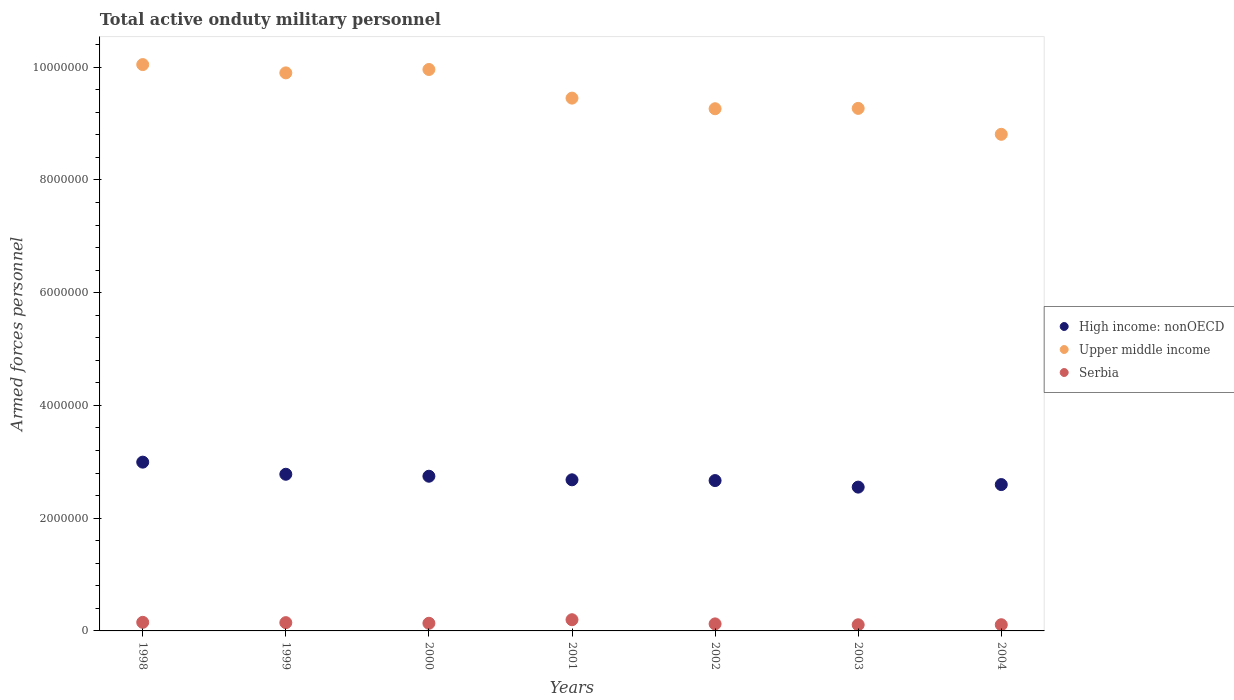How many different coloured dotlines are there?
Offer a very short reply. 3. What is the number of armed forces personnel in Upper middle income in 2002?
Your answer should be compact. 9.26e+06. Across all years, what is the maximum number of armed forces personnel in High income: nonOECD?
Keep it short and to the point. 2.99e+06. Across all years, what is the minimum number of armed forces personnel in Serbia?
Provide a short and direct response. 1.09e+05. In which year was the number of armed forces personnel in High income: nonOECD minimum?
Provide a short and direct response. 2003. What is the total number of armed forces personnel in High income: nonOECD in the graph?
Make the answer very short. 1.90e+07. What is the difference between the number of armed forces personnel in Upper middle income in 1998 and that in 2004?
Keep it short and to the point. 1.24e+06. What is the difference between the number of armed forces personnel in Upper middle income in 2001 and the number of armed forces personnel in High income: nonOECD in 2000?
Ensure brevity in your answer.  6.71e+06. What is the average number of armed forces personnel in Upper middle income per year?
Provide a succinct answer. 9.53e+06. In the year 2002, what is the difference between the number of armed forces personnel in Serbia and number of armed forces personnel in Upper middle income?
Offer a terse response. -9.14e+06. In how many years, is the number of armed forces personnel in Serbia greater than 4800000?
Your response must be concise. 0. What is the ratio of the number of armed forces personnel in High income: nonOECD in 1999 to that in 2001?
Provide a succinct answer. 1.04. What is the difference between the highest and the second highest number of armed forces personnel in High income: nonOECD?
Ensure brevity in your answer.  2.15e+05. What is the difference between the highest and the lowest number of armed forces personnel in Upper middle income?
Ensure brevity in your answer.  1.24e+06. Is the sum of the number of armed forces personnel in Upper middle income in 2000 and 2003 greater than the maximum number of armed forces personnel in High income: nonOECD across all years?
Offer a terse response. Yes. Does the number of armed forces personnel in High income: nonOECD monotonically increase over the years?
Keep it short and to the point. No. How many years are there in the graph?
Make the answer very short. 7. Are the values on the major ticks of Y-axis written in scientific E-notation?
Your answer should be compact. No. Does the graph contain any zero values?
Your response must be concise. No. How are the legend labels stacked?
Offer a very short reply. Vertical. What is the title of the graph?
Make the answer very short. Total active onduty military personnel. Does "Namibia" appear as one of the legend labels in the graph?
Provide a short and direct response. No. What is the label or title of the X-axis?
Your answer should be very brief. Years. What is the label or title of the Y-axis?
Keep it short and to the point. Armed forces personnel. What is the Armed forces personnel of High income: nonOECD in 1998?
Offer a terse response. 2.99e+06. What is the Armed forces personnel in Upper middle income in 1998?
Make the answer very short. 1.00e+07. What is the Armed forces personnel of Serbia in 1998?
Provide a succinct answer. 1.52e+05. What is the Armed forces personnel in High income: nonOECD in 1999?
Your answer should be compact. 2.78e+06. What is the Armed forces personnel in Upper middle income in 1999?
Provide a short and direct response. 9.90e+06. What is the Armed forces personnel of Serbia in 1999?
Your answer should be compact. 1.47e+05. What is the Armed forces personnel of High income: nonOECD in 2000?
Offer a very short reply. 2.74e+06. What is the Armed forces personnel in Upper middle income in 2000?
Your answer should be compact. 9.96e+06. What is the Armed forces personnel of Serbia in 2000?
Your answer should be compact. 1.36e+05. What is the Armed forces personnel of High income: nonOECD in 2001?
Your answer should be compact. 2.68e+06. What is the Armed forces personnel in Upper middle income in 2001?
Make the answer very short. 9.45e+06. What is the Armed forces personnel of Serbia in 2001?
Keep it short and to the point. 1.98e+05. What is the Armed forces personnel of High income: nonOECD in 2002?
Make the answer very short. 2.67e+06. What is the Armed forces personnel in Upper middle income in 2002?
Give a very brief answer. 9.26e+06. What is the Armed forces personnel in Serbia in 2002?
Offer a terse response. 1.24e+05. What is the Armed forces personnel of High income: nonOECD in 2003?
Your answer should be very brief. 2.55e+06. What is the Armed forces personnel in Upper middle income in 2003?
Ensure brevity in your answer.  9.27e+06. What is the Armed forces personnel of Serbia in 2003?
Offer a terse response. 1.09e+05. What is the Armed forces personnel of High income: nonOECD in 2004?
Provide a short and direct response. 2.60e+06. What is the Armed forces personnel of Upper middle income in 2004?
Make the answer very short. 8.81e+06. What is the Armed forces personnel of Serbia in 2004?
Your response must be concise. 1.10e+05. Across all years, what is the maximum Armed forces personnel in High income: nonOECD?
Keep it short and to the point. 2.99e+06. Across all years, what is the maximum Armed forces personnel in Upper middle income?
Provide a short and direct response. 1.00e+07. Across all years, what is the maximum Armed forces personnel of Serbia?
Offer a very short reply. 1.98e+05. Across all years, what is the minimum Armed forces personnel of High income: nonOECD?
Your response must be concise. 2.55e+06. Across all years, what is the minimum Armed forces personnel of Upper middle income?
Provide a short and direct response. 8.81e+06. Across all years, what is the minimum Armed forces personnel in Serbia?
Provide a succinct answer. 1.09e+05. What is the total Armed forces personnel of High income: nonOECD in the graph?
Provide a succinct answer. 1.90e+07. What is the total Armed forces personnel in Upper middle income in the graph?
Your response must be concise. 6.67e+07. What is the total Armed forces personnel in Serbia in the graph?
Offer a terse response. 9.77e+05. What is the difference between the Armed forces personnel of High income: nonOECD in 1998 and that in 1999?
Your answer should be compact. 2.15e+05. What is the difference between the Armed forces personnel in Upper middle income in 1998 and that in 1999?
Provide a succinct answer. 1.47e+05. What is the difference between the Armed forces personnel in Serbia in 1998 and that in 1999?
Ensure brevity in your answer.  5500. What is the difference between the Armed forces personnel in High income: nonOECD in 1998 and that in 2000?
Offer a terse response. 2.50e+05. What is the difference between the Armed forces personnel in Upper middle income in 1998 and that in 2000?
Your response must be concise. 8.70e+04. What is the difference between the Armed forces personnel in Serbia in 1998 and that in 2000?
Your answer should be compact. 1.65e+04. What is the difference between the Armed forces personnel of High income: nonOECD in 1998 and that in 2001?
Keep it short and to the point. 3.13e+05. What is the difference between the Armed forces personnel of Upper middle income in 1998 and that in 2001?
Provide a short and direct response. 5.95e+05. What is the difference between the Armed forces personnel in Serbia in 1998 and that in 2001?
Ensure brevity in your answer.  -4.63e+04. What is the difference between the Armed forces personnel of High income: nonOECD in 1998 and that in 2002?
Offer a terse response. 3.27e+05. What is the difference between the Armed forces personnel of Upper middle income in 1998 and that in 2002?
Provide a short and direct response. 7.83e+05. What is the difference between the Armed forces personnel in Serbia in 1998 and that in 2002?
Your response must be concise. 2.77e+04. What is the difference between the Armed forces personnel in High income: nonOECD in 1998 and that in 2003?
Make the answer very short. 4.43e+05. What is the difference between the Armed forces personnel in Upper middle income in 1998 and that in 2003?
Your answer should be very brief. 7.77e+05. What is the difference between the Armed forces personnel of Serbia in 1998 and that in 2003?
Your answer should be compact. 4.30e+04. What is the difference between the Armed forces personnel of High income: nonOECD in 1998 and that in 2004?
Your response must be concise. 3.98e+05. What is the difference between the Armed forces personnel of Upper middle income in 1998 and that in 2004?
Your answer should be very brief. 1.24e+06. What is the difference between the Armed forces personnel in Serbia in 1998 and that in 2004?
Offer a very short reply. 4.22e+04. What is the difference between the Armed forces personnel of High income: nonOECD in 1999 and that in 2000?
Give a very brief answer. 3.48e+04. What is the difference between the Armed forces personnel of Upper middle income in 1999 and that in 2000?
Your answer should be very brief. -6.02e+04. What is the difference between the Armed forces personnel of Serbia in 1999 and that in 2000?
Your answer should be very brief. 1.10e+04. What is the difference between the Armed forces personnel in High income: nonOECD in 1999 and that in 2001?
Your answer should be compact. 9.84e+04. What is the difference between the Armed forces personnel in Upper middle income in 1999 and that in 2001?
Offer a very short reply. 4.48e+05. What is the difference between the Armed forces personnel of Serbia in 1999 and that in 2001?
Provide a short and direct response. -5.18e+04. What is the difference between the Armed forces personnel in High income: nonOECD in 1999 and that in 2002?
Your response must be concise. 1.12e+05. What is the difference between the Armed forces personnel in Upper middle income in 1999 and that in 2002?
Offer a terse response. 6.36e+05. What is the difference between the Armed forces personnel in Serbia in 1999 and that in 2002?
Ensure brevity in your answer.  2.22e+04. What is the difference between the Armed forces personnel of High income: nonOECD in 1999 and that in 2003?
Make the answer very short. 2.28e+05. What is the difference between the Armed forces personnel of Upper middle income in 1999 and that in 2003?
Give a very brief answer. 6.30e+05. What is the difference between the Armed forces personnel in Serbia in 1999 and that in 2003?
Keep it short and to the point. 3.75e+04. What is the difference between the Armed forces personnel of High income: nonOECD in 1999 and that in 2004?
Provide a short and direct response. 1.83e+05. What is the difference between the Armed forces personnel of Upper middle income in 1999 and that in 2004?
Keep it short and to the point. 1.09e+06. What is the difference between the Armed forces personnel in Serbia in 1999 and that in 2004?
Your response must be concise. 3.67e+04. What is the difference between the Armed forces personnel of High income: nonOECD in 2000 and that in 2001?
Make the answer very short. 6.36e+04. What is the difference between the Armed forces personnel of Upper middle income in 2000 and that in 2001?
Offer a very short reply. 5.08e+05. What is the difference between the Armed forces personnel in Serbia in 2000 and that in 2001?
Your answer should be compact. -6.28e+04. What is the difference between the Armed forces personnel of High income: nonOECD in 2000 and that in 2002?
Make the answer very short. 7.70e+04. What is the difference between the Armed forces personnel of Upper middle income in 2000 and that in 2002?
Your response must be concise. 6.96e+05. What is the difference between the Armed forces personnel in Serbia in 2000 and that in 2002?
Provide a short and direct response. 1.12e+04. What is the difference between the Armed forces personnel in High income: nonOECD in 2000 and that in 2003?
Your answer should be compact. 1.93e+05. What is the difference between the Armed forces personnel in Upper middle income in 2000 and that in 2003?
Ensure brevity in your answer.  6.90e+05. What is the difference between the Armed forces personnel of Serbia in 2000 and that in 2003?
Offer a very short reply. 2.65e+04. What is the difference between the Armed forces personnel of High income: nonOECD in 2000 and that in 2004?
Give a very brief answer. 1.48e+05. What is the difference between the Armed forces personnel in Upper middle income in 2000 and that in 2004?
Ensure brevity in your answer.  1.15e+06. What is the difference between the Armed forces personnel of Serbia in 2000 and that in 2004?
Your response must be concise. 2.57e+04. What is the difference between the Armed forces personnel of High income: nonOECD in 2001 and that in 2002?
Your response must be concise. 1.34e+04. What is the difference between the Armed forces personnel in Upper middle income in 2001 and that in 2002?
Provide a succinct answer. 1.88e+05. What is the difference between the Armed forces personnel of Serbia in 2001 and that in 2002?
Provide a short and direct response. 7.40e+04. What is the difference between the Armed forces personnel in High income: nonOECD in 2001 and that in 2003?
Make the answer very short. 1.30e+05. What is the difference between the Armed forces personnel of Upper middle income in 2001 and that in 2003?
Your answer should be compact. 1.82e+05. What is the difference between the Armed forces personnel in Serbia in 2001 and that in 2003?
Make the answer very short. 8.93e+04. What is the difference between the Armed forces personnel in High income: nonOECD in 2001 and that in 2004?
Ensure brevity in your answer.  8.45e+04. What is the difference between the Armed forces personnel of Upper middle income in 2001 and that in 2004?
Give a very brief answer. 6.42e+05. What is the difference between the Armed forces personnel of Serbia in 2001 and that in 2004?
Your response must be concise. 8.85e+04. What is the difference between the Armed forces personnel of High income: nonOECD in 2002 and that in 2003?
Give a very brief answer. 1.16e+05. What is the difference between the Armed forces personnel of Upper middle income in 2002 and that in 2003?
Make the answer very short. -6300. What is the difference between the Armed forces personnel in Serbia in 2002 and that in 2003?
Provide a short and direct response. 1.53e+04. What is the difference between the Armed forces personnel of High income: nonOECD in 2002 and that in 2004?
Make the answer very short. 7.11e+04. What is the difference between the Armed forces personnel of Upper middle income in 2002 and that in 2004?
Give a very brief answer. 4.54e+05. What is the difference between the Armed forces personnel of Serbia in 2002 and that in 2004?
Your answer should be very brief. 1.45e+04. What is the difference between the Armed forces personnel of High income: nonOECD in 2003 and that in 2004?
Your answer should be compact. -4.51e+04. What is the difference between the Armed forces personnel of Upper middle income in 2003 and that in 2004?
Keep it short and to the point. 4.60e+05. What is the difference between the Armed forces personnel in Serbia in 2003 and that in 2004?
Ensure brevity in your answer.  -800. What is the difference between the Armed forces personnel of High income: nonOECD in 1998 and the Armed forces personnel of Upper middle income in 1999?
Provide a succinct answer. -6.91e+06. What is the difference between the Armed forces personnel in High income: nonOECD in 1998 and the Armed forces personnel in Serbia in 1999?
Offer a terse response. 2.85e+06. What is the difference between the Armed forces personnel of Upper middle income in 1998 and the Armed forces personnel of Serbia in 1999?
Offer a very short reply. 9.90e+06. What is the difference between the Armed forces personnel of High income: nonOECD in 1998 and the Armed forces personnel of Upper middle income in 2000?
Give a very brief answer. -6.97e+06. What is the difference between the Armed forces personnel in High income: nonOECD in 1998 and the Armed forces personnel in Serbia in 2000?
Provide a short and direct response. 2.86e+06. What is the difference between the Armed forces personnel in Upper middle income in 1998 and the Armed forces personnel in Serbia in 2000?
Your answer should be very brief. 9.91e+06. What is the difference between the Armed forces personnel in High income: nonOECD in 1998 and the Armed forces personnel in Upper middle income in 2001?
Offer a terse response. -6.46e+06. What is the difference between the Armed forces personnel in High income: nonOECD in 1998 and the Armed forces personnel in Serbia in 2001?
Provide a short and direct response. 2.80e+06. What is the difference between the Armed forces personnel in Upper middle income in 1998 and the Armed forces personnel in Serbia in 2001?
Provide a short and direct response. 9.85e+06. What is the difference between the Armed forces personnel in High income: nonOECD in 1998 and the Armed forces personnel in Upper middle income in 2002?
Offer a terse response. -6.27e+06. What is the difference between the Armed forces personnel of High income: nonOECD in 1998 and the Armed forces personnel of Serbia in 2002?
Offer a terse response. 2.87e+06. What is the difference between the Armed forces personnel in Upper middle income in 1998 and the Armed forces personnel in Serbia in 2002?
Your response must be concise. 9.92e+06. What is the difference between the Armed forces personnel in High income: nonOECD in 1998 and the Armed forces personnel in Upper middle income in 2003?
Your answer should be compact. -6.28e+06. What is the difference between the Armed forces personnel of High income: nonOECD in 1998 and the Armed forces personnel of Serbia in 2003?
Your answer should be very brief. 2.88e+06. What is the difference between the Armed forces personnel in Upper middle income in 1998 and the Armed forces personnel in Serbia in 2003?
Make the answer very short. 9.94e+06. What is the difference between the Armed forces personnel in High income: nonOECD in 1998 and the Armed forces personnel in Upper middle income in 2004?
Your answer should be very brief. -5.82e+06. What is the difference between the Armed forces personnel in High income: nonOECD in 1998 and the Armed forces personnel in Serbia in 2004?
Make the answer very short. 2.88e+06. What is the difference between the Armed forces personnel in Upper middle income in 1998 and the Armed forces personnel in Serbia in 2004?
Provide a short and direct response. 9.94e+06. What is the difference between the Armed forces personnel of High income: nonOECD in 1999 and the Armed forces personnel of Upper middle income in 2000?
Provide a succinct answer. -7.18e+06. What is the difference between the Armed forces personnel in High income: nonOECD in 1999 and the Armed forces personnel in Serbia in 2000?
Give a very brief answer. 2.64e+06. What is the difference between the Armed forces personnel in Upper middle income in 1999 and the Armed forces personnel in Serbia in 2000?
Your response must be concise. 9.76e+06. What is the difference between the Armed forces personnel of High income: nonOECD in 1999 and the Armed forces personnel of Upper middle income in 2001?
Keep it short and to the point. -6.67e+06. What is the difference between the Armed forces personnel in High income: nonOECD in 1999 and the Armed forces personnel in Serbia in 2001?
Give a very brief answer. 2.58e+06. What is the difference between the Armed forces personnel of Upper middle income in 1999 and the Armed forces personnel of Serbia in 2001?
Keep it short and to the point. 9.70e+06. What is the difference between the Armed forces personnel in High income: nonOECD in 1999 and the Armed forces personnel in Upper middle income in 2002?
Keep it short and to the point. -6.48e+06. What is the difference between the Armed forces personnel of High income: nonOECD in 1999 and the Armed forces personnel of Serbia in 2002?
Your response must be concise. 2.65e+06. What is the difference between the Armed forces personnel in Upper middle income in 1999 and the Armed forces personnel in Serbia in 2002?
Offer a terse response. 9.78e+06. What is the difference between the Armed forces personnel in High income: nonOECD in 1999 and the Armed forces personnel in Upper middle income in 2003?
Your answer should be very brief. -6.49e+06. What is the difference between the Armed forces personnel in High income: nonOECD in 1999 and the Armed forces personnel in Serbia in 2003?
Ensure brevity in your answer.  2.67e+06. What is the difference between the Armed forces personnel in Upper middle income in 1999 and the Armed forces personnel in Serbia in 2003?
Give a very brief answer. 9.79e+06. What is the difference between the Armed forces personnel of High income: nonOECD in 1999 and the Armed forces personnel of Upper middle income in 2004?
Offer a very short reply. -6.03e+06. What is the difference between the Armed forces personnel in High income: nonOECD in 1999 and the Armed forces personnel in Serbia in 2004?
Offer a very short reply. 2.67e+06. What is the difference between the Armed forces personnel of Upper middle income in 1999 and the Armed forces personnel of Serbia in 2004?
Your response must be concise. 9.79e+06. What is the difference between the Armed forces personnel in High income: nonOECD in 2000 and the Armed forces personnel in Upper middle income in 2001?
Provide a short and direct response. -6.71e+06. What is the difference between the Armed forces personnel in High income: nonOECD in 2000 and the Armed forces personnel in Serbia in 2001?
Ensure brevity in your answer.  2.55e+06. What is the difference between the Armed forces personnel of Upper middle income in 2000 and the Armed forces personnel of Serbia in 2001?
Offer a very short reply. 9.76e+06. What is the difference between the Armed forces personnel in High income: nonOECD in 2000 and the Armed forces personnel in Upper middle income in 2002?
Provide a succinct answer. -6.52e+06. What is the difference between the Armed forces personnel in High income: nonOECD in 2000 and the Armed forces personnel in Serbia in 2002?
Offer a very short reply. 2.62e+06. What is the difference between the Armed forces personnel of Upper middle income in 2000 and the Armed forces personnel of Serbia in 2002?
Make the answer very short. 9.84e+06. What is the difference between the Armed forces personnel in High income: nonOECD in 2000 and the Armed forces personnel in Upper middle income in 2003?
Offer a very short reply. -6.53e+06. What is the difference between the Armed forces personnel in High income: nonOECD in 2000 and the Armed forces personnel in Serbia in 2003?
Make the answer very short. 2.64e+06. What is the difference between the Armed forces personnel of Upper middle income in 2000 and the Armed forces personnel of Serbia in 2003?
Your answer should be compact. 9.85e+06. What is the difference between the Armed forces personnel in High income: nonOECD in 2000 and the Armed forces personnel in Upper middle income in 2004?
Make the answer very short. -6.07e+06. What is the difference between the Armed forces personnel of High income: nonOECD in 2000 and the Armed forces personnel of Serbia in 2004?
Make the answer very short. 2.63e+06. What is the difference between the Armed forces personnel in Upper middle income in 2000 and the Armed forces personnel in Serbia in 2004?
Your response must be concise. 9.85e+06. What is the difference between the Armed forces personnel of High income: nonOECD in 2001 and the Armed forces personnel of Upper middle income in 2002?
Give a very brief answer. -6.58e+06. What is the difference between the Armed forces personnel of High income: nonOECD in 2001 and the Armed forces personnel of Serbia in 2002?
Provide a succinct answer. 2.56e+06. What is the difference between the Armed forces personnel in Upper middle income in 2001 and the Armed forces personnel in Serbia in 2002?
Make the answer very short. 9.33e+06. What is the difference between the Armed forces personnel in High income: nonOECD in 2001 and the Armed forces personnel in Upper middle income in 2003?
Your answer should be very brief. -6.59e+06. What is the difference between the Armed forces personnel in High income: nonOECD in 2001 and the Armed forces personnel in Serbia in 2003?
Your answer should be very brief. 2.57e+06. What is the difference between the Armed forces personnel in Upper middle income in 2001 and the Armed forces personnel in Serbia in 2003?
Your answer should be very brief. 9.34e+06. What is the difference between the Armed forces personnel of High income: nonOECD in 2001 and the Armed forces personnel of Upper middle income in 2004?
Ensure brevity in your answer.  -6.13e+06. What is the difference between the Armed forces personnel in High income: nonOECD in 2001 and the Armed forces personnel in Serbia in 2004?
Provide a short and direct response. 2.57e+06. What is the difference between the Armed forces personnel in Upper middle income in 2001 and the Armed forces personnel in Serbia in 2004?
Give a very brief answer. 9.34e+06. What is the difference between the Armed forces personnel in High income: nonOECD in 2002 and the Armed forces personnel in Upper middle income in 2003?
Keep it short and to the point. -6.60e+06. What is the difference between the Armed forces personnel of High income: nonOECD in 2002 and the Armed forces personnel of Serbia in 2003?
Provide a succinct answer. 2.56e+06. What is the difference between the Armed forces personnel in Upper middle income in 2002 and the Armed forces personnel in Serbia in 2003?
Offer a very short reply. 9.15e+06. What is the difference between the Armed forces personnel of High income: nonOECD in 2002 and the Armed forces personnel of Upper middle income in 2004?
Offer a terse response. -6.14e+06. What is the difference between the Armed forces personnel in High income: nonOECD in 2002 and the Armed forces personnel in Serbia in 2004?
Your answer should be very brief. 2.56e+06. What is the difference between the Armed forces personnel in Upper middle income in 2002 and the Armed forces personnel in Serbia in 2004?
Ensure brevity in your answer.  9.15e+06. What is the difference between the Armed forces personnel in High income: nonOECD in 2003 and the Armed forces personnel in Upper middle income in 2004?
Offer a very short reply. -6.26e+06. What is the difference between the Armed forces personnel in High income: nonOECD in 2003 and the Armed forces personnel in Serbia in 2004?
Make the answer very short. 2.44e+06. What is the difference between the Armed forces personnel of Upper middle income in 2003 and the Armed forces personnel of Serbia in 2004?
Your response must be concise. 9.16e+06. What is the average Armed forces personnel of High income: nonOECD per year?
Ensure brevity in your answer.  2.72e+06. What is the average Armed forces personnel in Upper middle income per year?
Keep it short and to the point. 9.53e+06. What is the average Armed forces personnel in Serbia per year?
Make the answer very short. 1.40e+05. In the year 1998, what is the difference between the Armed forces personnel in High income: nonOECD and Armed forces personnel in Upper middle income?
Ensure brevity in your answer.  -7.05e+06. In the year 1998, what is the difference between the Armed forces personnel of High income: nonOECD and Armed forces personnel of Serbia?
Provide a succinct answer. 2.84e+06. In the year 1998, what is the difference between the Armed forces personnel of Upper middle income and Armed forces personnel of Serbia?
Provide a short and direct response. 9.89e+06. In the year 1999, what is the difference between the Armed forces personnel in High income: nonOECD and Armed forces personnel in Upper middle income?
Make the answer very short. -7.12e+06. In the year 1999, what is the difference between the Armed forces personnel in High income: nonOECD and Armed forces personnel in Serbia?
Provide a short and direct response. 2.63e+06. In the year 1999, what is the difference between the Armed forces personnel of Upper middle income and Armed forces personnel of Serbia?
Offer a very short reply. 9.75e+06. In the year 2000, what is the difference between the Armed forces personnel of High income: nonOECD and Armed forces personnel of Upper middle income?
Give a very brief answer. -7.22e+06. In the year 2000, what is the difference between the Armed forces personnel of High income: nonOECD and Armed forces personnel of Serbia?
Make the answer very short. 2.61e+06. In the year 2000, what is the difference between the Armed forces personnel in Upper middle income and Armed forces personnel in Serbia?
Make the answer very short. 9.82e+06. In the year 2001, what is the difference between the Armed forces personnel in High income: nonOECD and Armed forces personnel in Upper middle income?
Your response must be concise. -6.77e+06. In the year 2001, what is the difference between the Armed forces personnel of High income: nonOECD and Armed forces personnel of Serbia?
Provide a short and direct response. 2.48e+06. In the year 2001, what is the difference between the Armed forces personnel in Upper middle income and Armed forces personnel in Serbia?
Make the answer very short. 9.25e+06. In the year 2002, what is the difference between the Armed forces personnel of High income: nonOECD and Armed forces personnel of Upper middle income?
Keep it short and to the point. -6.60e+06. In the year 2002, what is the difference between the Armed forces personnel in High income: nonOECD and Armed forces personnel in Serbia?
Your answer should be very brief. 2.54e+06. In the year 2002, what is the difference between the Armed forces personnel in Upper middle income and Armed forces personnel in Serbia?
Ensure brevity in your answer.  9.14e+06. In the year 2003, what is the difference between the Armed forces personnel of High income: nonOECD and Armed forces personnel of Upper middle income?
Ensure brevity in your answer.  -6.72e+06. In the year 2003, what is the difference between the Armed forces personnel of High income: nonOECD and Armed forces personnel of Serbia?
Your answer should be compact. 2.44e+06. In the year 2003, what is the difference between the Armed forces personnel of Upper middle income and Armed forces personnel of Serbia?
Offer a very short reply. 9.16e+06. In the year 2004, what is the difference between the Armed forces personnel of High income: nonOECD and Armed forces personnel of Upper middle income?
Provide a succinct answer. -6.21e+06. In the year 2004, what is the difference between the Armed forces personnel in High income: nonOECD and Armed forces personnel in Serbia?
Offer a terse response. 2.49e+06. In the year 2004, what is the difference between the Armed forces personnel of Upper middle income and Armed forces personnel of Serbia?
Make the answer very short. 8.70e+06. What is the ratio of the Armed forces personnel in High income: nonOECD in 1998 to that in 1999?
Provide a succinct answer. 1.08. What is the ratio of the Armed forces personnel of Upper middle income in 1998 to that in 1999?
Give a very brief answer. 1.01. What is the ratio of the Armed forces personnel in Serbia in 1998 to that in 1999?
Ensure brevity in your answer.  1.04. What is the ratio of the Armed forces personnel in High income: nonOECD in 1998 to that in 2000?
Offer a terse response. 1.09. What is the ratio of the Armed forces personnel of Upper middle income in 1998 to that in 2000?
Offer a very short reply. 1.01. What is the ratio of the Armed forces personnel in Serbia in 1998 to that in 2000?
Your answer should be very brief. 1.12. What is the ratio of the Armed forces personnel in High income: nonOECD in 1998 to that in 2001?
Offer a very short reply. 1.12. What is the ratio of the Armed forces personnel of Upper middle income in 1998 to that in 2001?
Provide a succinct answer. 1.06. What is the ratio of the Armed forces personnel in Serbia in 1998 to that in 2001?
Give a very brief answer. 0.77. What is the ratio of the Armed forces personnel in High income: nonOECD in 1998 to that in 2002?
Offer a terse response. 1.12. What is the ratio of the Armed forces personnel of Upper middle income in 1998 to that in 2002?
Your response must be concise. 1.08. What is the ratio of the Armed forces personnel of Serbia in 1998 to that in 2002?
Give a very brief answer. 1.22. What is the ratio of the Armed forces personnel in High income: nonOECD in 1998 to that in 2003?
Offer a terse response. 1.17. What is the ratio of the Armed forces personnel of Upper middle income in 1998 to that in 2003?
Make the answer very short. 1.08. What is the ratio of the Armed forces personnel in Serbia in 1998 to that in 2003?
Offer a terse response. 1.39. What is the ratio of the Armed forces personnel of High income: nonOECD in 1998 to that in 2004?
Offer a terse response. 1.15. What is the ratio of the Armed forces personnel of Upper middle income in 1998 to that in 2004?
Make the answer very short. 1.14. What is the ratio of the Armed forces personnel in Serbia in 1998 to that in 2004?
Make the answer very short. 1.38. What is the ratio of the Armed forces personnel in High income: nonOECD in 1999 to that in 2000?
Provide a short and direct response. 1.01. What is the ratio of the Armed forces personnel in Serbia in 1999 to that in 2000?
Ensure brevity in your answer.  1.08. What is the ratio of the Armed forces personnel of High income: nonOECD in 1999 to that in 2001?
Your answer should be compact. 1.04. What is the ratio of the Armed forces personnel of Upper middle income in 1999 to that in 2001?
Offer a very short reply. 1.05. What is the ratio of the Armed forces personnel in Serbia in 1999 to that in 2001?
Offer a very short reply. 0.74. What is the ratio of the Armed forces personnel in High income: nonOECD in 1999 to that in 2002?
Provide a short and direct response. 1.04. What is the ratio of the Armed forces personnel in Upper middle income in 1999 to that in 2002?
Your answer should be compact. 1.07. What is the ratio of the Armed forces personnel of Serbia in 1999 to that in 2002?
Offer a terse response. 1.18. What is the ratio of the Armed forces personnel in High income: nonOECD in 1999 to that in 2003?
Your response must be concise. 1.09. What is the ratio of the Armed forces personnel of Upper middle income in 1999 to that in 2003?
Offer a terse response. 1.07. What is the ratio of the Armed forces personnel of Serbia in 1999 to that in 2003?
Ensure brevity in your answer.  1.34. What is the ratio of the Armed forces personnel in High income: nonOECD in 1999 to that in 2004?
Provide a short and direct response. 1.07. What is the ratio of the Armed forces personnel of Upper middle income in 1999 to that in 2004?
Provide a short and direct response. 1.12. What is the ratio of the Armed forces personnel of Serbia in 1999 to that in 2004?
Ensure brevity in your answer.  1.33. What is the ratio of the Armed forces personnel of High income: nonOECD in 2000 to that in 2001?
Provide a short and direct response. 1.02. What is the ratio of the Armed forces personnel of Upper middle income in 2000 to that in 2001?
Your answer should be very brief. 1.05. What is the ratio of the Armed forces personnel of Serbia in 2000 to that in 2001?
Make the answer very short. 0.68. What is the ratio of the Armed forces personnel of High income: nonOECD in 2000 to that in 2002?
Offer a very short reply. 1.03. What is the ratio of the Armed forces personnel of Upper middle income in 2000 to that in 2002?
Provide a succinct answer. 1.08. What is the ratio of the Armed forces personnel of Serbia in 2000 to that in 2002?
Give a very brief answer. 1.09. What is the ratio of the Armed forces personnel in High income: nonOECD in 2000 to that in 2003?
Give a very brief answer. 1.08. What is the ratio of the Armed forces personnel of Upper middle income in 2000 to that in 2003?
Offer a terse response. 1.07. What is the ratio of the Armed forces personnel in Serbia in 2000 to that in 2003?
Keep it short and to the point. 1.24. What is the ratio of the Armed forces personnel of High income: nonOECD in 2000 to that in 2004?
Make the answer very short. 1.06. What is the ratio of the Armed forces personnel of Upper middle income in 2000 to that in 2004?
Your answer should be compact. 1.13. What is the ratio of the Armed forces personnel of Serbia in 2000 to that in 2004?
Your response must be concise. 1.23. What is the ratio of the Armed forces personnel of Upper middle income in 2001 to that in 2002?
Your response must be concise. 1.02. What is the ratio of the Armed forces personnel of Serbia in 2001 to that in 2002?
Give a very brief answer. 1.59. What is the ratio of the Armed forces personnel in High income: nonOECD in 2001 to that in 2003?
Your response must be concise. 1.05. What is the ratio of the Armed forces personnel in Upper middle income in 2001 to that in 2003?
Ensure brevity in your answer.  1.02. What is the ratio of the Armed forces personnel of Serbia in 2001 to that in 2003?
Your answer should be very brief. 1.82. What is the ratio of the Armed forces personnel of High income: nonOECD in 2001 to that in 2004?
Provide a short and direct response. 1.03. What is the ratio of the Armed forces personnel in Upper middle income in 2001 to that in 2004?
Keep it short and to the point. 1.07. What is the ratio of the Armed forces personnel in Serbia in 2001 to that in 2004?
Make the answer very short. 1.8. What is the ratio of the Armed forces personnel of High income: nonOECD in 2002 to that in 2003?
Your answer should be compact. 1.05. What is the ratio of the Armed forces personnel of Upper middle income in 2002 to that in 2003?
Offer a terse response. 1. What is the ratio of the Armed forces personnel in Serbia in 2002 to that in 2003?
Provide a short and direct response. 1.14. What is the ratio of the Armed forces personnel of High income: nonOECD in 2002 to that in 2004?
Ensure brevity in your answer.  1.03. What is the ratio of the Armed forces personnel in Upper middle income in 2002 to that in 2004?
Your answer should be very brief. 1.05. What is the ratio of the Armed forces personnel in Serbia in 2002 to that in 2004?
Your response must be concise. 1.13. What is the ratio of the Armed forces personnel in High income: nonOECD in 2003 to that in 2004?
Ensure brevity in your answer.  0.98. What is the ratio of the Armed forces personnel of Upper middle income in 2003 to that in 2004?
Make the answer very short. 1.05. What is the difference between the highest and the second highest Armed forces personnel in High income: nonOECD?
Offer a terse response. 2.15e+05. What is the difference between the highest and the second highest Armed forces personnel in Upper middle income?
Your answer should be very brief. 8.70e+04. What is the difference between the highest and the second highest Armed forces personnel in Serbia?
Your answer should be compact. 4.63e+04. What is the difference between the highest and the lowest Armed forces personnel in High income: nonOECD?
Your answer should be compact. 4.43e+05. What is the difference between the highest and the lowest Armed forces personnel of Upper middle income?
Keep it short and to the point. 1.24e+06. What is the difference between the highest and the lowest Armed forces personnel in Serbia?
Provide a short and direct response. 8.93e+04. 